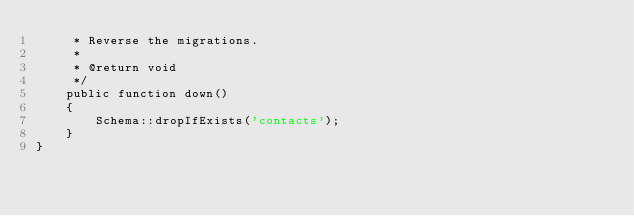Convert code to text. <code><loc_0><loc_0><loc_500><loc_500><_PHP_>     * Reverse the migrations.
     *
     * @return void
     */
    public function down()
    {
        Schema::dropIfExists('contacts');
    }
}
</code> 